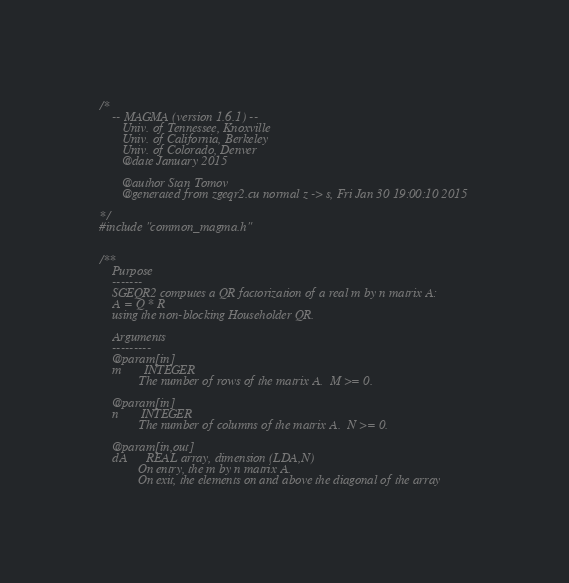Convert code to text. <code><loc_0><loc_0><loc_500><loc_500><_Cuda_>/*
    -- MAGMA (version 1.6.1) --
       Univ. of Tennessee, Knoxville
       Univ. of California, Berkeley
       Univ. of Colorado, Denver
       @date January 2015

       @author Stan Tomov
       @generated from zgeqr2.cu normal z -> s, Fri Jan 30 19:00:10 2015

*/
#include "common_magma.h"


/**
    Purpose
    -------
    SGEQR2 computes a QR factorization of a real m by n matrix A:
    A = Q * R
    using the non-blocking Householder QR.

    Arguments
    ---------
    @param[in]
    m       INTEGER
            The number of rows of the matrix A.  M >= 0.

    @param[in]
    n       INTEGER
            The number of columns of the matrix A.  N >= 0.

    @param[in,out]
    dA      REAL array, dimension (LDA,N)
            On entry, the m by n matrix A.
            On exit, the elements on and above the diagonal of the array</code> 